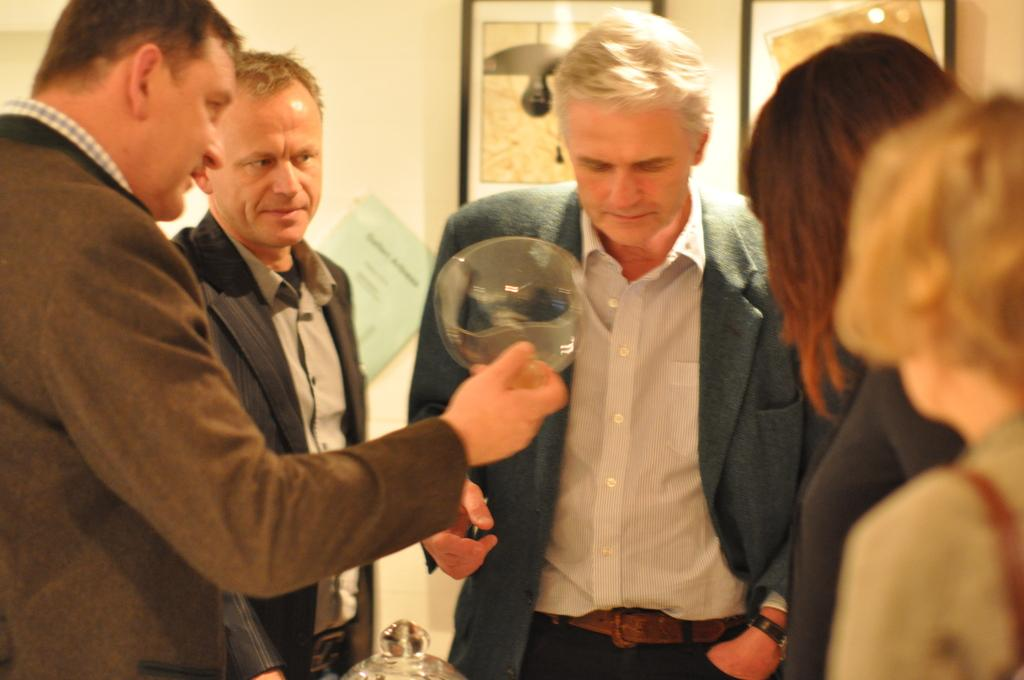What is happening in the image? There are people standing in the image. Can you describe the clothing of the people? The people are wearing different color dresses. What is one person doing in the image? One person is holding something. What can be seen in the background of the image? There are frames and a wall visible in the background. What type of slip is the person wearing in the image? There is no mention of a slip in the image, as the focus is on the people standing and their clothing. 